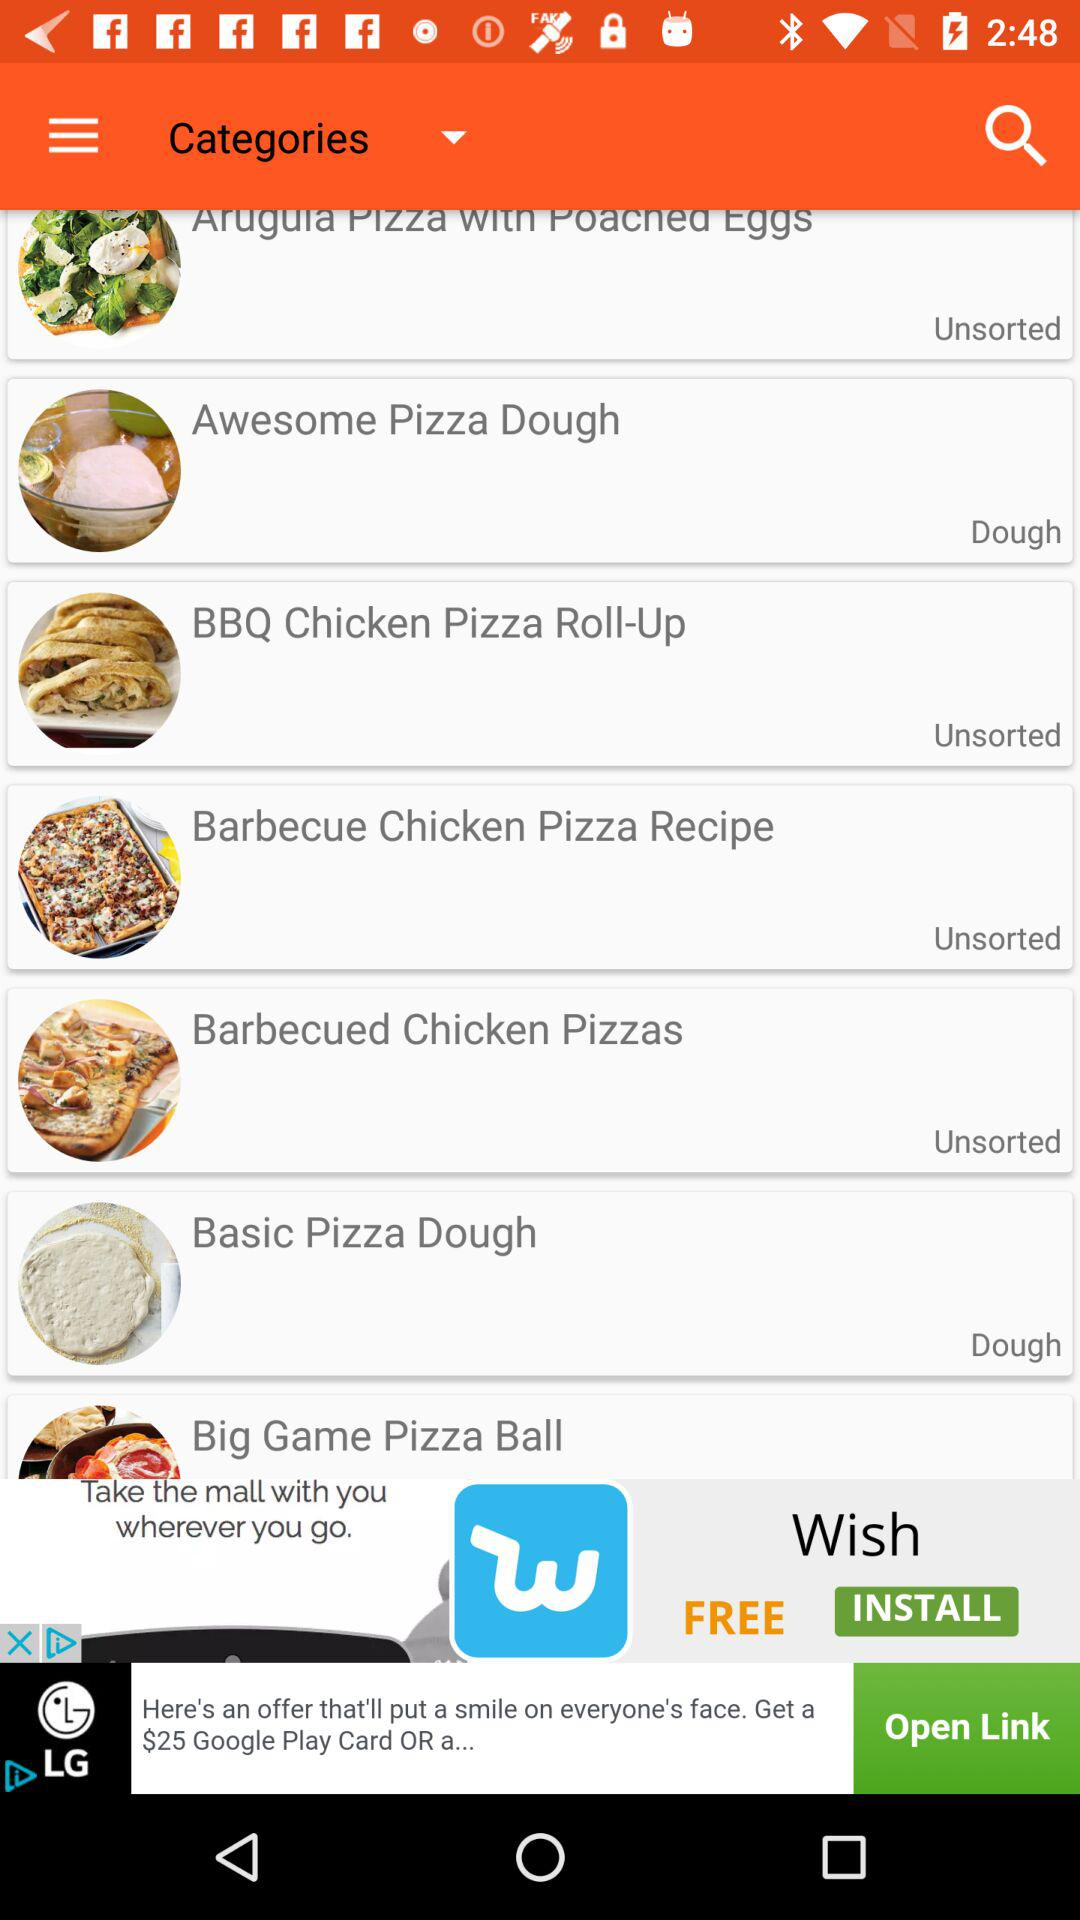What are the unsorted recipes? The unsorted recipes are "BBQ Chicken Pizza Roll-Up", "Barbecue Chicken Pizza Recipe" and "Barbecued Chicken Pizzas". 